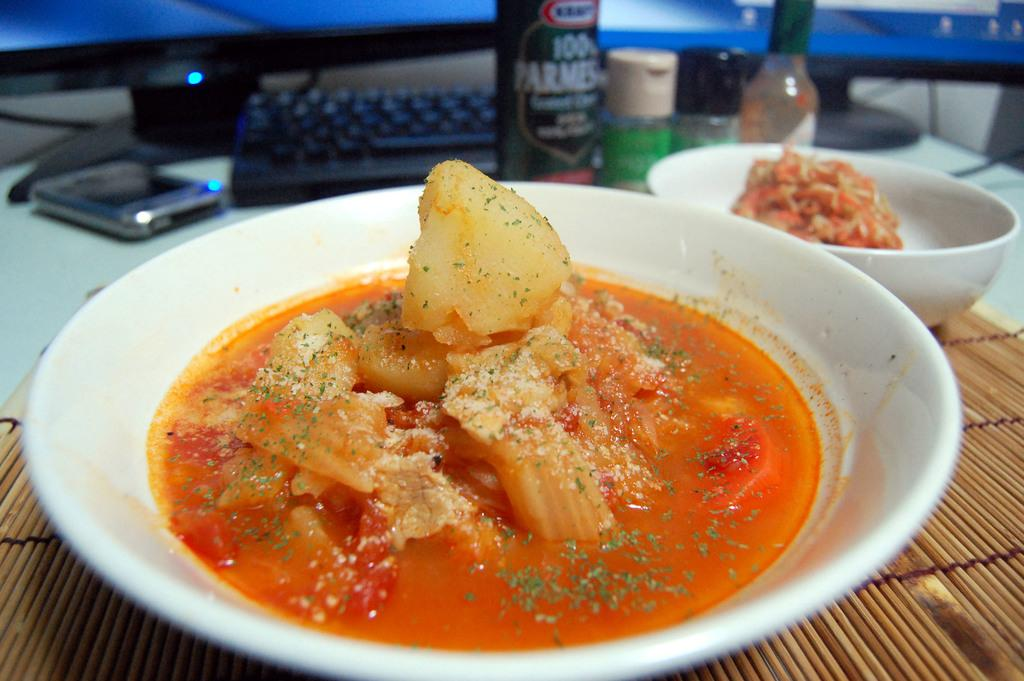What type of food is in the plate in the image? There is food in a plate in the image, but the specific type of food is not mentioned. What type of food is in the bowl in the image? There is food in a bowl in the image, but the specific type of food is not mentioned. What are the bottles beside the plate in the image? The bottles beside the plate in the image are not described in detail, so we cannot determine their contents or purpose. Where is the mobile located in the image? The mobile is on the table in the image. What is the keyboard used for in the image? The keyboard on the table in the image is likely used for typing or inputting information, but its specific purpose is not mentioned. What can be seen on the monitors in the image? The monitors in the image are not described in detail, so we cannot determine what is displayed on them. How many tomatoes are on the cake in the image? There is no cake or tomatoes present in the image. What step is being taken by the person in the image? There is no person present in the image, so we cannot determine any actions or steps being taken. 